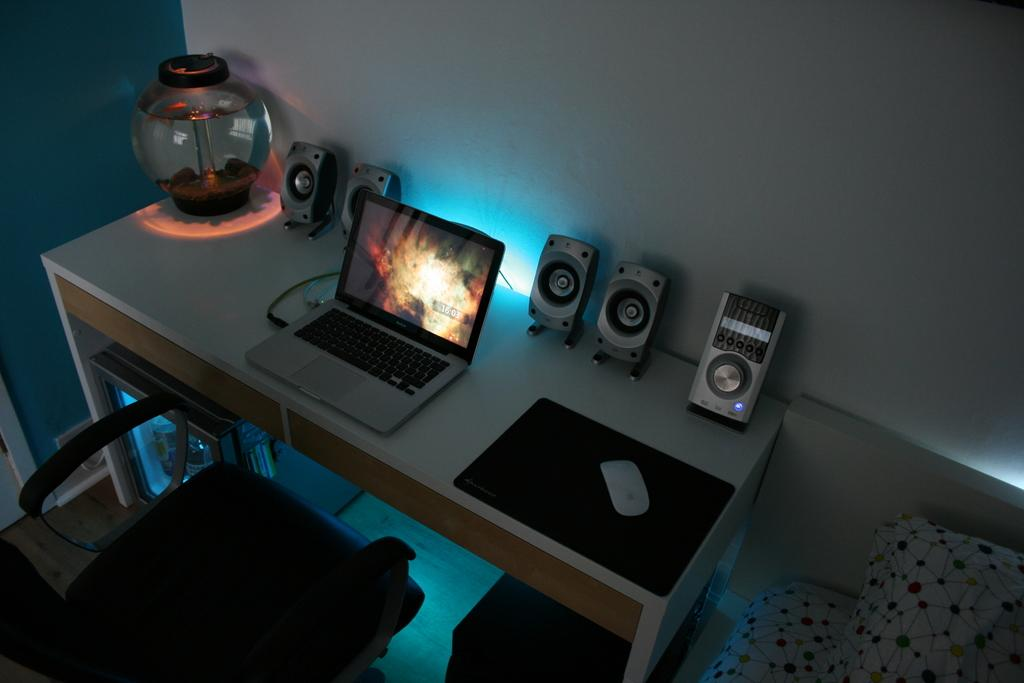What type of structure can be seen in the image? There is a wall in the image. What type of furniture is present in the image? There is a chair and a table in the image. What is on the table in the image? There is a pot, a laptop, a mouse, and a mat on the table. What grade does the laptop in the image have? The laptop in the image does not have a grade, as it is an electronic device and not a student. What type of apparatus is used to control the laptop in the image? There is no apparatus mentioned in the image; the laptop is controlled using the mouse that is also present on the table. 